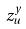<formula> <loc_0><loc_0><loc_500><loc_500>z _ { u } ^ { y }</formula> 